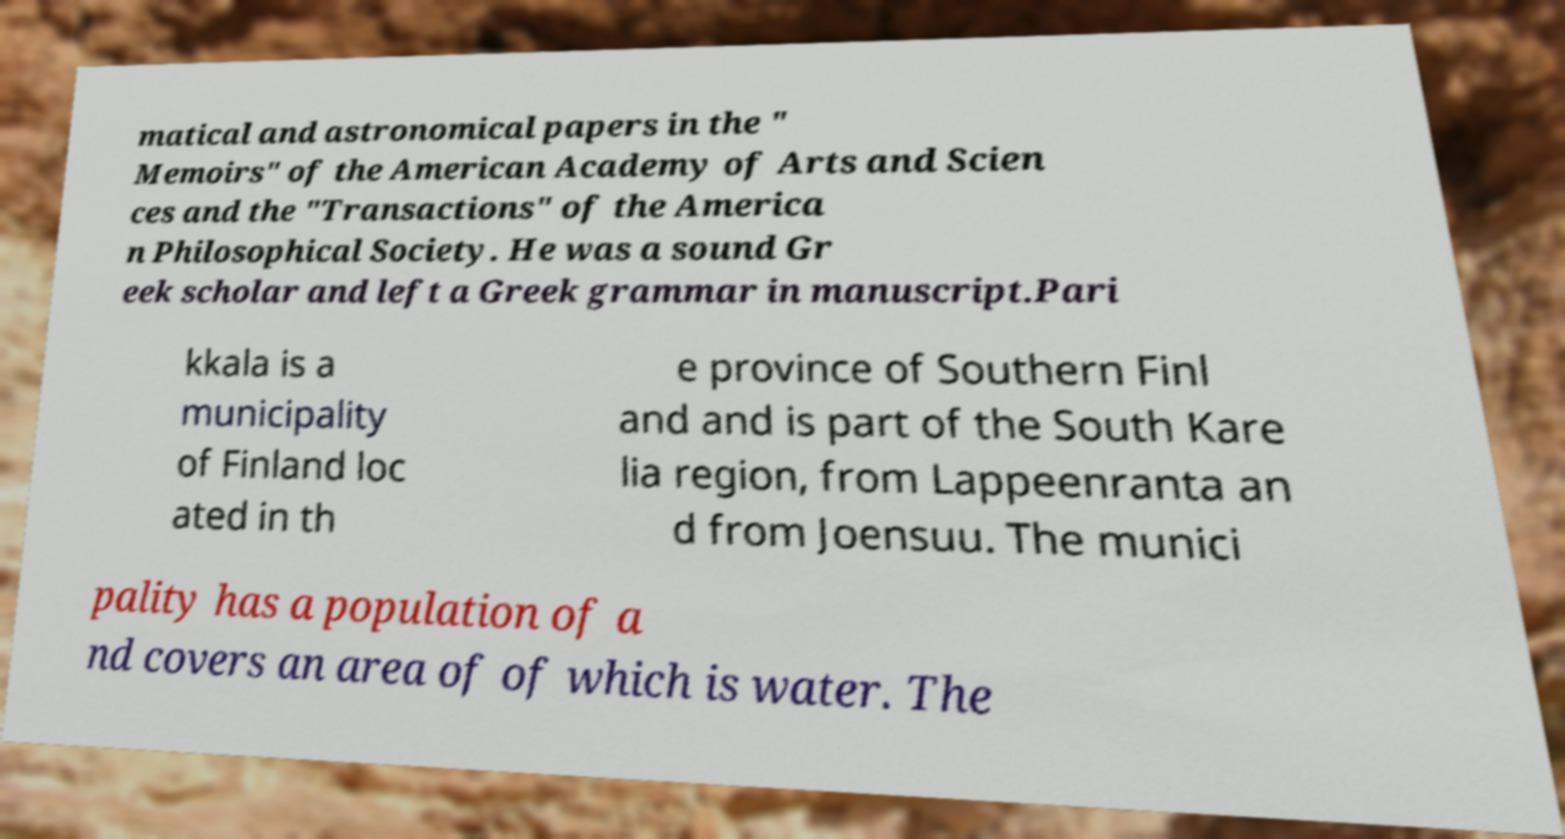Please read and relay the text visible in this image. What does it say? matical and astronomical papers in the " Memoirs" of the American Academy of Arts and Scien ces and the "Transactions" of the America n Philosophical Society. He was a sound Gr eek scholar and left a Greek grammar in manuscript.Pari kkala is a municipality of Finland loc ated in th e province of Southern Finl and and is part of the South Kare lia region, from Lappeenranta an d from Joensuu. The munici pality has a population of a nd covers an area of of which is water. The 